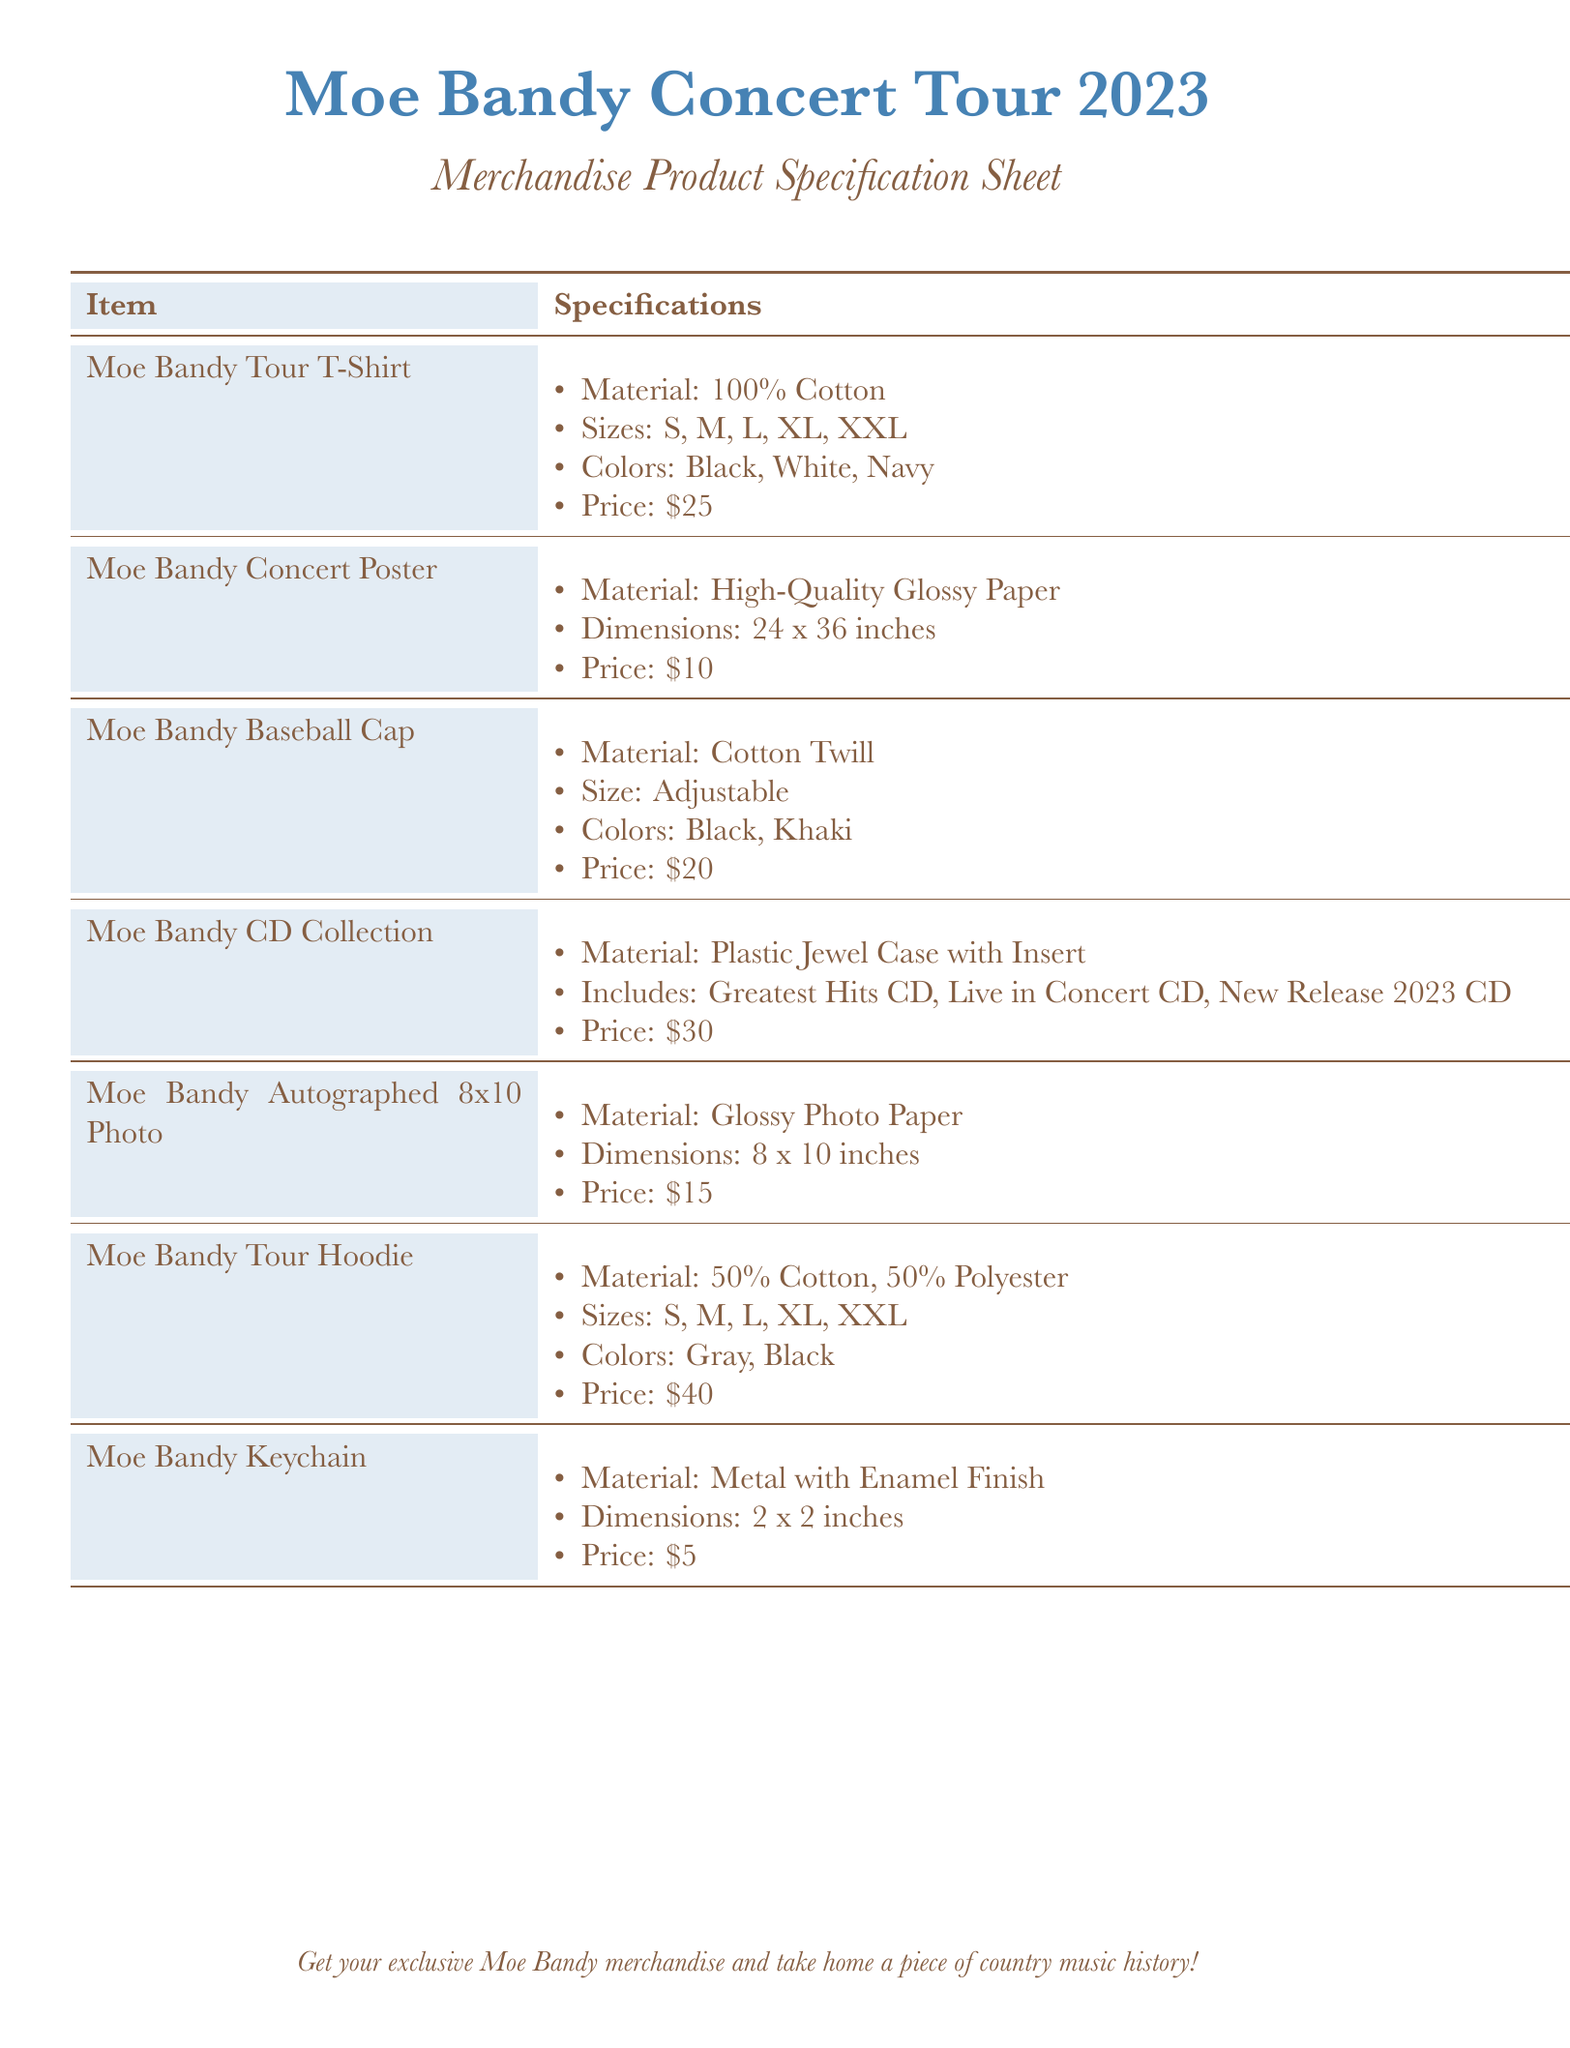What is the price of the Moe Bandy Tour T-Shirt? The price of the Moe Bandy Tour T-Shirt is listed on the specification sheet.
Answer: $25 What materials are used for the Moe Bandy Concert Poster? The materials for the Moe Bandy Concert Poster are specified in the product details.
Answer: High-Quality Glossy Paper How many sizes are available for the Moe Bandy Tour Hoodie? The number of sizes is indicated in the specifications for the hoodies.
Answer: 5 What colors are available for the Moe Bandy Baseball Cap? The specifications list the colors for the baseball cap.
Answer: Black, Khaki What is the size of the Moe Bandy Autographed 8x10 Photo? The dimensions of the photo are provided in the specification sheet details.
Answer: 8 x 10 inches Which item has a price of $40? The price is clearly stated in the merchandise specification.
Answer: Moe Bandy Tour Hoodie What type of case does the Moe Bandy CD Collection come in? The product details provide the type of case for the CD Collection.
Answer: Plastic Jewel Case with Insert What item is made of Metal with Enamel Finish? The material for the keychain is specified in its product details.
Answer: Moe Bandy Keychain 